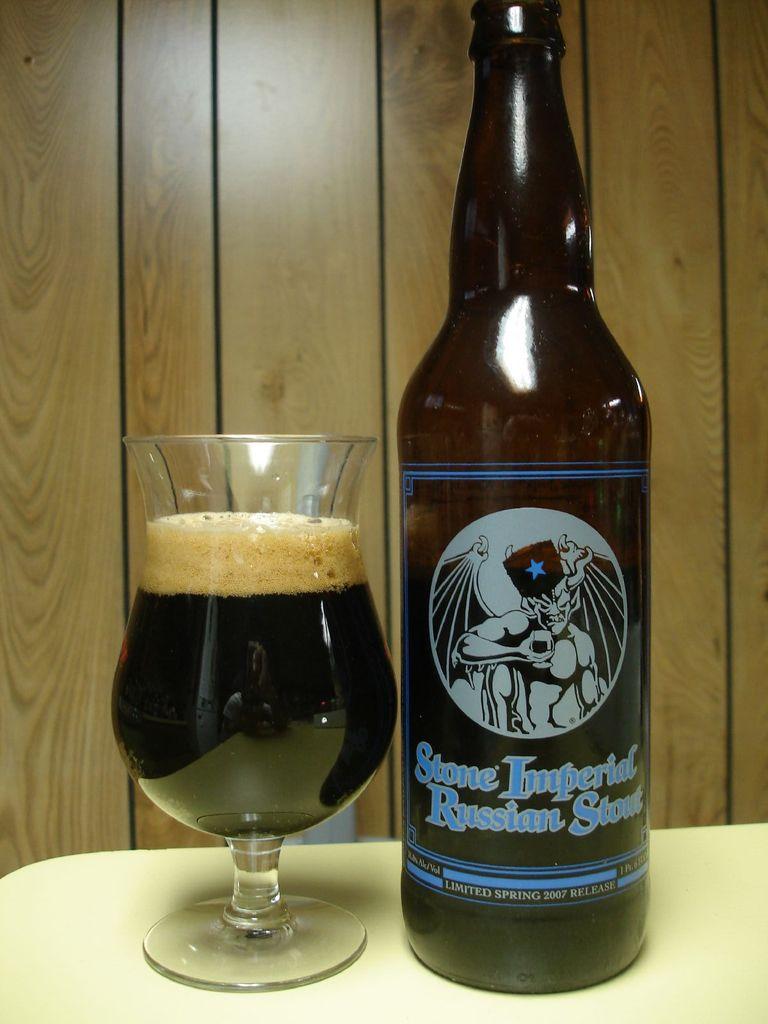What is the name of the russian stout?
Your response must be concise. Stone imperial. 